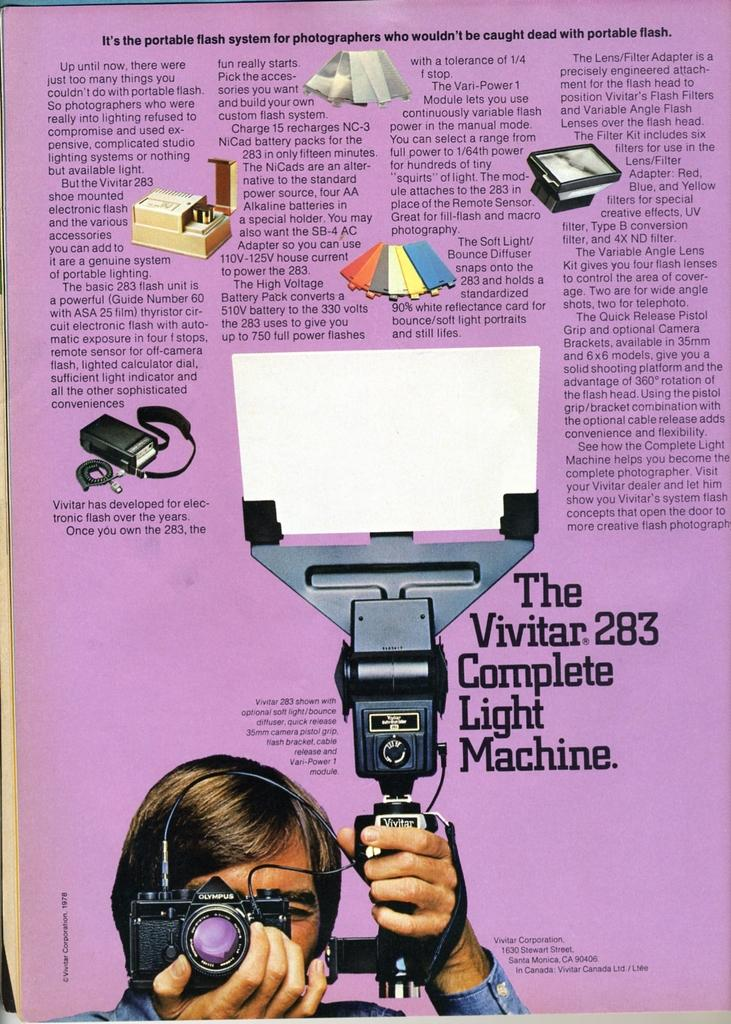What is the main subject of the newspaper cutting in the image? The newspaper cutting features a person holding a camera in their hand. What can be seen in the background of the newspaper cutting? There are objects visible in the newspaper cutting. What type of information is present in the newspaper cutting? There is text present in the newspaper cutting. What type of apparel is the person wearing in the image? There is no information about the person's apparel in the image, as it only features a newspaper cutting with a person holding a camera. 